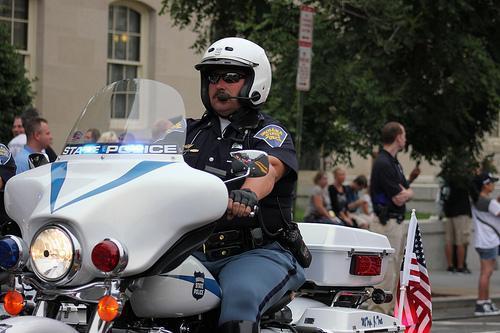How many of the the motorcycle's lights are on?
Give a very brief answer. 1. How many people are sitting on the cement partition?
Give a very brief answer. 3. How many people are wearing police clothes?
Give a very brief answer. 1. 